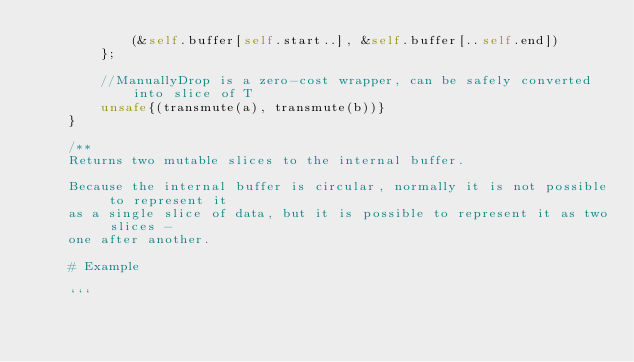<code> <loc_0><loc_0><loc_500><loc_500><_Rust_>            (&self.buffer[self.start..], &self.buffer[..self.end])
        };

        //ManuallyDrop is a zero-cost wrapper, can be safely converted into slice of T
        unsafe{(transmute(a), transmute(b))}
    }

    /**
    Returns two mutable slices to the internal buffer.

    Because the internal buffer is circular, normally it is not possible to represent it
    as a single slice of data, but it is possible to represent it as two slices -
    one after another.

    # Example

    ```</code> 